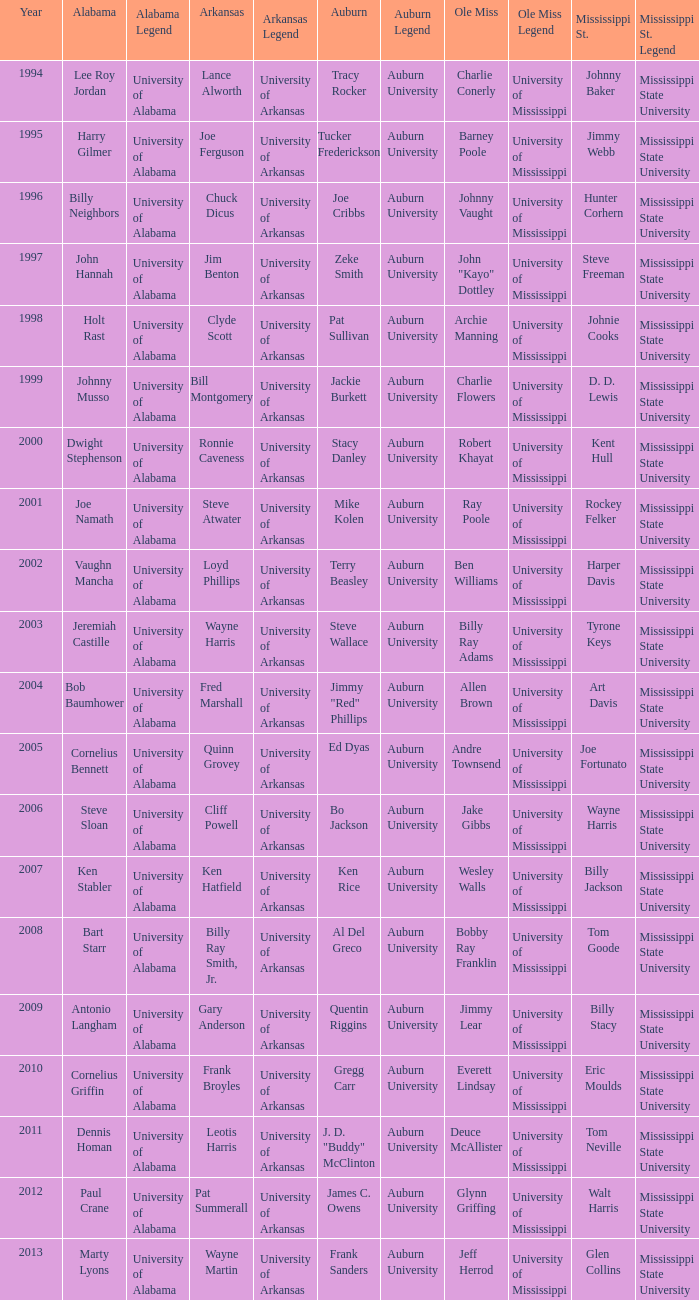Who was the Mississippi State player associated with Cornelius Bennett? Joe Fortunato. 